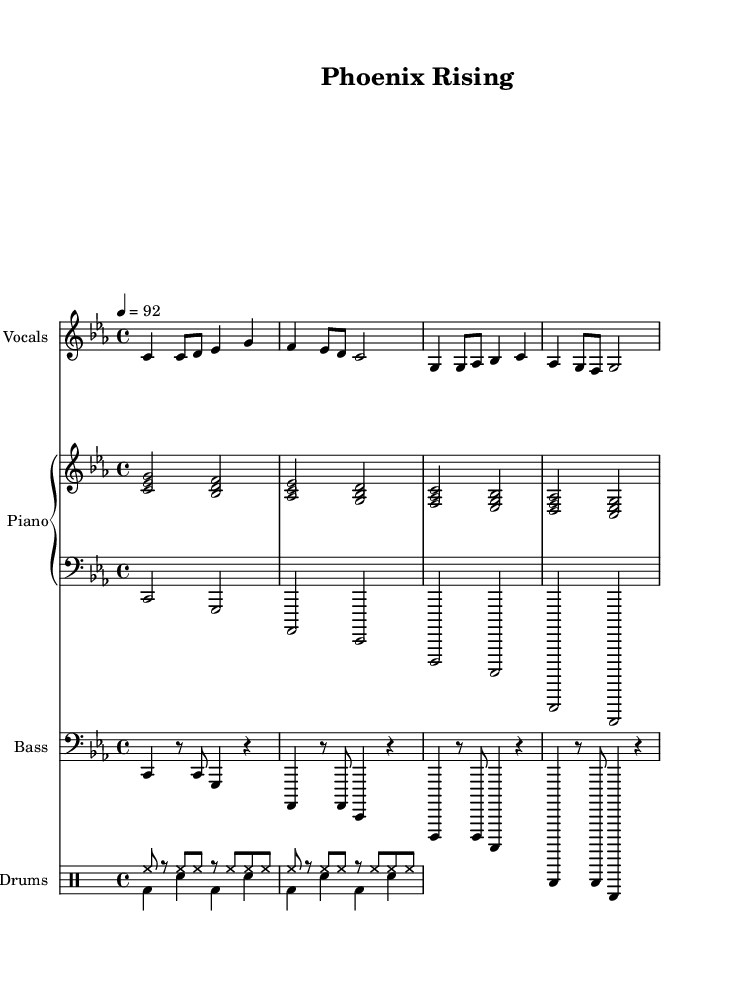what is the key signature of this music? The key signature is C minor, which has three flats: B flat, E flat, and A flat. This is identified at the beginning of the sheet music, where the key signature is indicated.
Answer: C minor what is the time signature of this music? The time signature is 4/4, which means there are four beats per measure and a quarter note gets one beat. This can be found at the beginning of the sheet music.
Answer: 4/4 what is the tempo marking for this piece? The tempo marking is 92 beats per minute, indicated at the beginning of the music, which provides the performance speed for the piece.
Answer: 92 how many measures are in the lead vocals section? There are eight measures in the lead vocals section; each line of music corresponds to four measures, and there are two lines given for the lead vocals.
Answer: 8 what do the lyrics convey in the chorus? The lyrics of the chorus express themes of transformation and the embrace of second chances, highlighting the idea of rising and spreading wings. This is indicated through the text above the corresponding notes in the sheet music.
Answer: Transformation how does the instrumental arrangement support the theme of redemption? The arrangement features a combination of lead vocals, piano, bass, and drums, creating a rich sound that underscores the emotionally charged lyrics about overcoming struggles and seeking redemption. This interplay enhances the overall message of transformation throughout the piece.
Answer: Rich sound what is the musical structure of the piece? The structure consists of verses and a chorus, a common format in hip hop that allows for storytelling through the verses followed by a repeated chorus that emphasizes the central message of the song.
Answer: Verses and chorus 